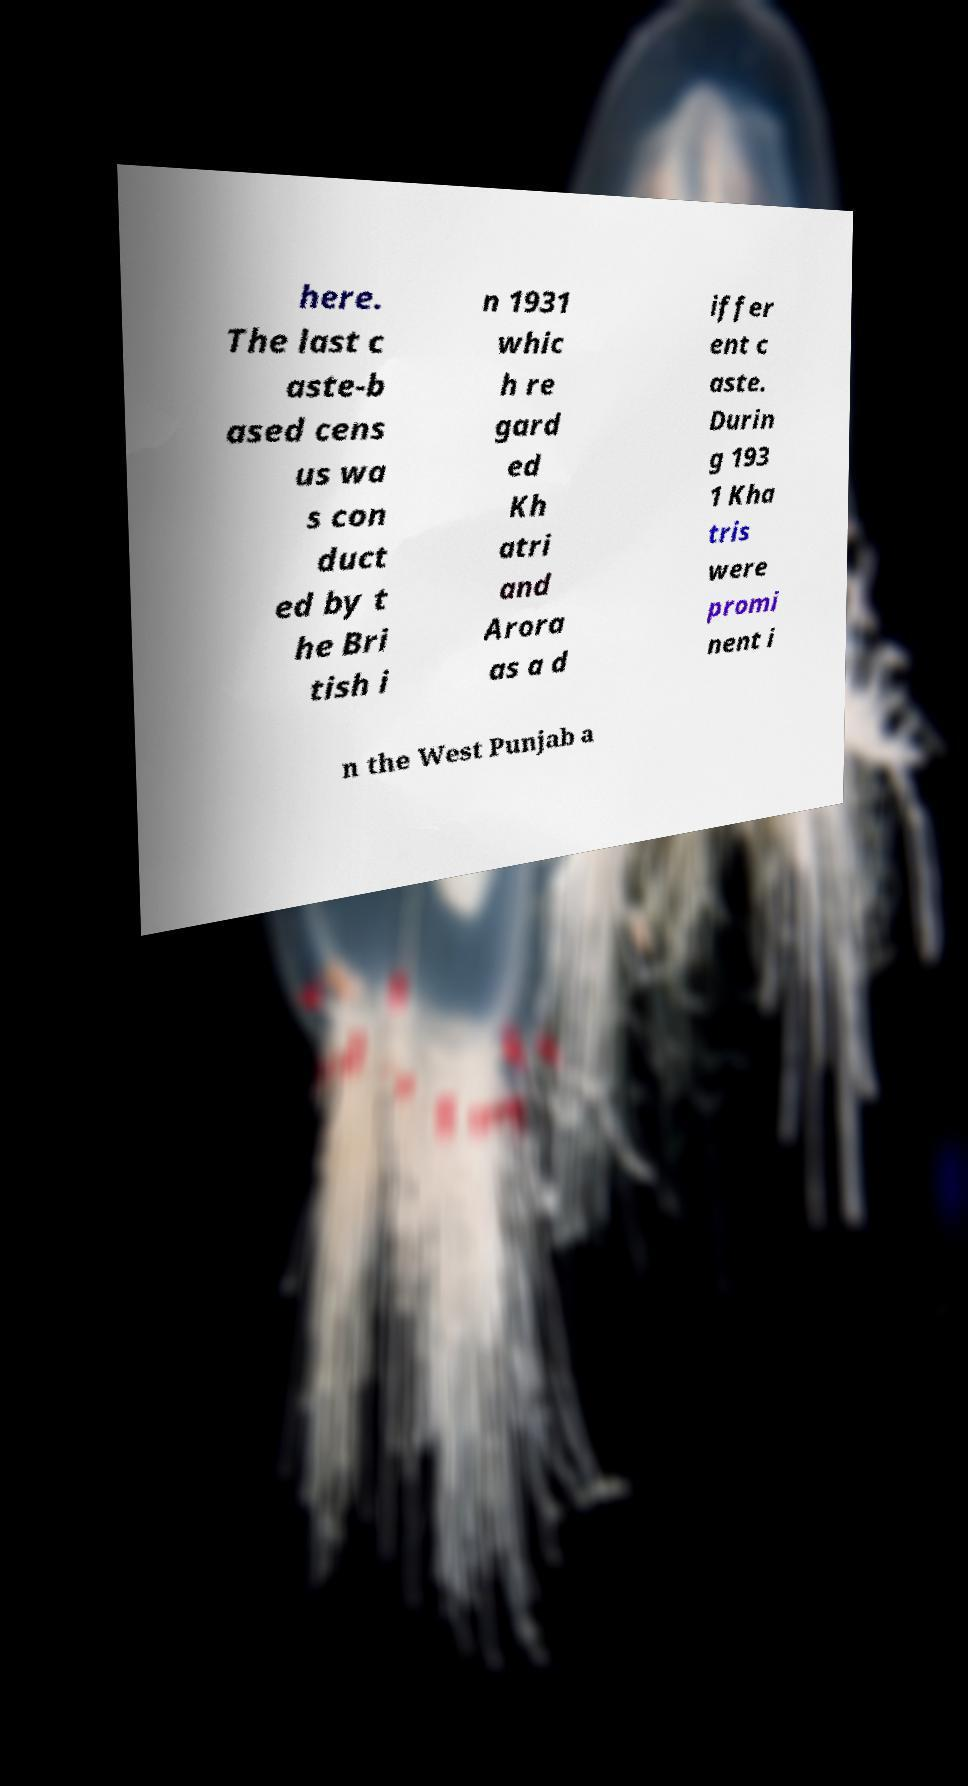What messages or text are displayed in this image? I need them in a readable, typed format. here. The last c aste-b ased cens us wa s con duct ed by t he Bri tish i n 1931 whic h re gard ed Kh atri and Arora as a d iffer ent c aste. Durin g 193 1 Kha tris were promi nent i n the West Punjab a 